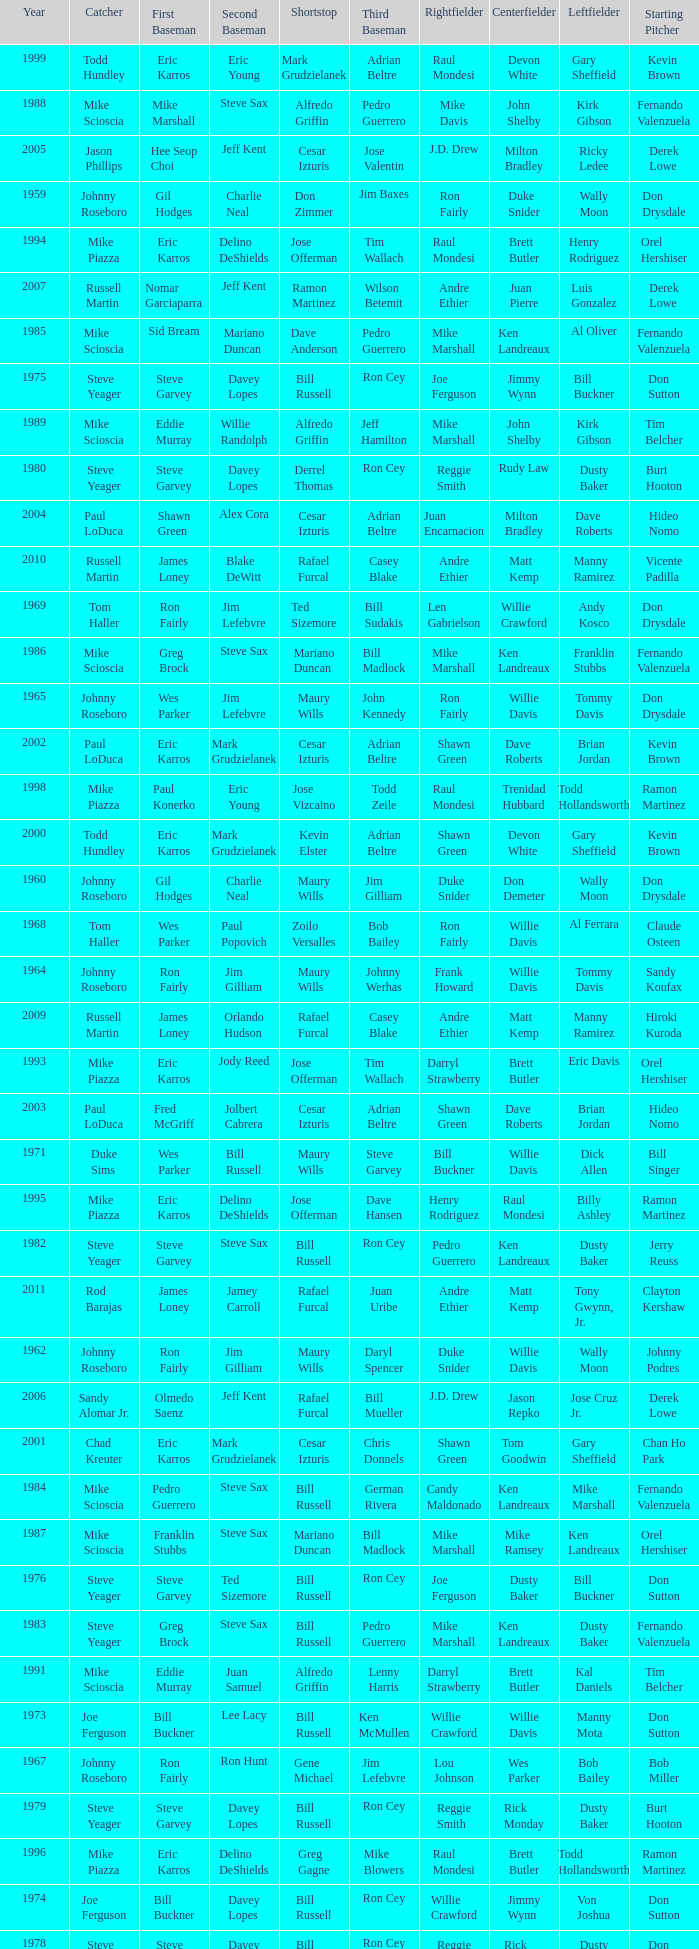Who was the RF when the SP was vicente padilla? Andre Ethier. 